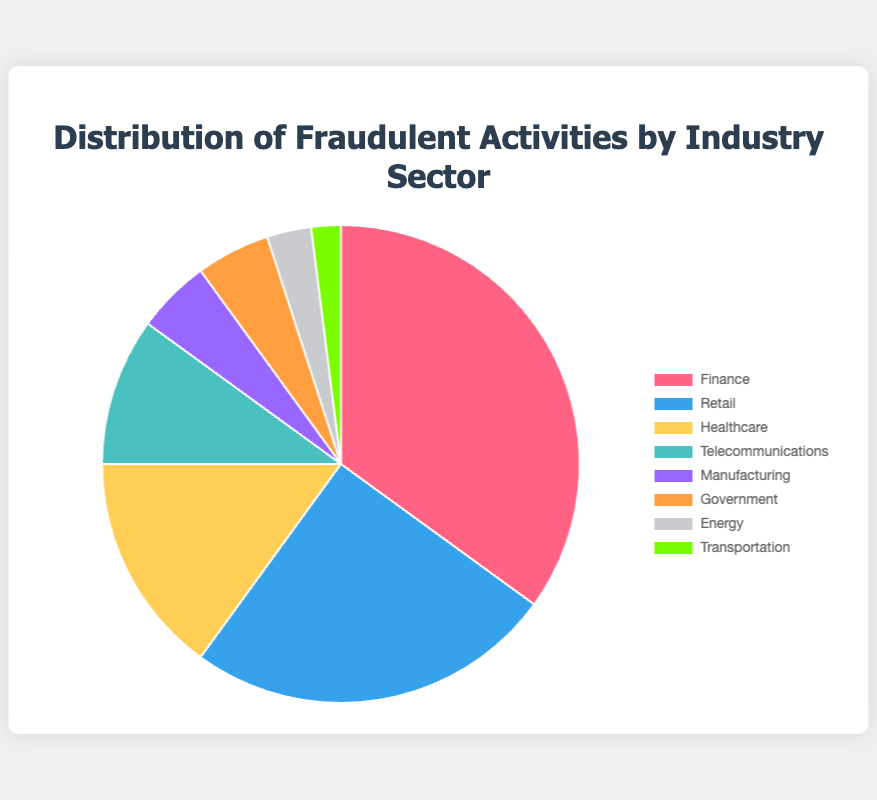What is the industry sector with the highest percentage of fraudulent activities? The industry with the highest percentage of fraudulent activities is identified by looking at the largest slice of the pie chart, which represents 35%. This slice corresponds to the Finance sector.
Answer: Finance Which two industry sectors together make up the same percentage as the Finance sector? To find two sectors whose combined percentages equal that of the Finance sector (35%), we can look at Retail (25%) and Healthcare (15%). Their combined percentage is 25% + 15% = 40%, which is close to but exceeds the Finance sector. The exact match would be Manufacturing (5%) combined with Retail (25%) and Government (5%).
Answer: Retail and Healthcare How much higher is the percentage of fraudulent activities in the Healthcare sector compared to the Energy sector? Healthcare has 15% and Energy has 3%. To find the difference: 15% - 3% = 12%.
Answer: 12% Which industry sectors have the same percentage of fraudulent activities? By examining the pie chart, we can see that the slices for Manufacturing and Government both represent 5%.
Answer: Manufacturing and Government What is the combined percentage of fraudulent activities in Telecommunications and Transportation sectors? Telecommunications has 10% and Transportation has 2%. Adding them together: 10% + 2% = 12%.
Answer: 12% What percentage of fraudulent activities are accounted for by the four smallest sectors combined? Adding the percentages of the four smallest sectors: Manufacturing (5%), Government (5%), Energy (3%), and Transportation (2%) gives: 5% + 5% + 3% + 2% = 15%.
Answer: 15% What is the visual representation color of the Retail sector? The Retail sector slice is represented by the color blue in the pie chart.
Answer: Blue How does the percentage of fraudulent activities in the Telecommunications sector compare to that in the Healthcare sector? Telecommunications has 10% while Healthcare has 15%. Comparing these, Healthcare has a higher percentage of fraudulent activities: 15% - 10% = 5%.
Answer: Healthcare is 5% higher Which sector has a lower percentage of fraudulent activities, Energy or Government? By comparing the slices, Energy has 3% and Government has 5%. Thus, Energy has a lower percentage than Government.
Answer: Energy 